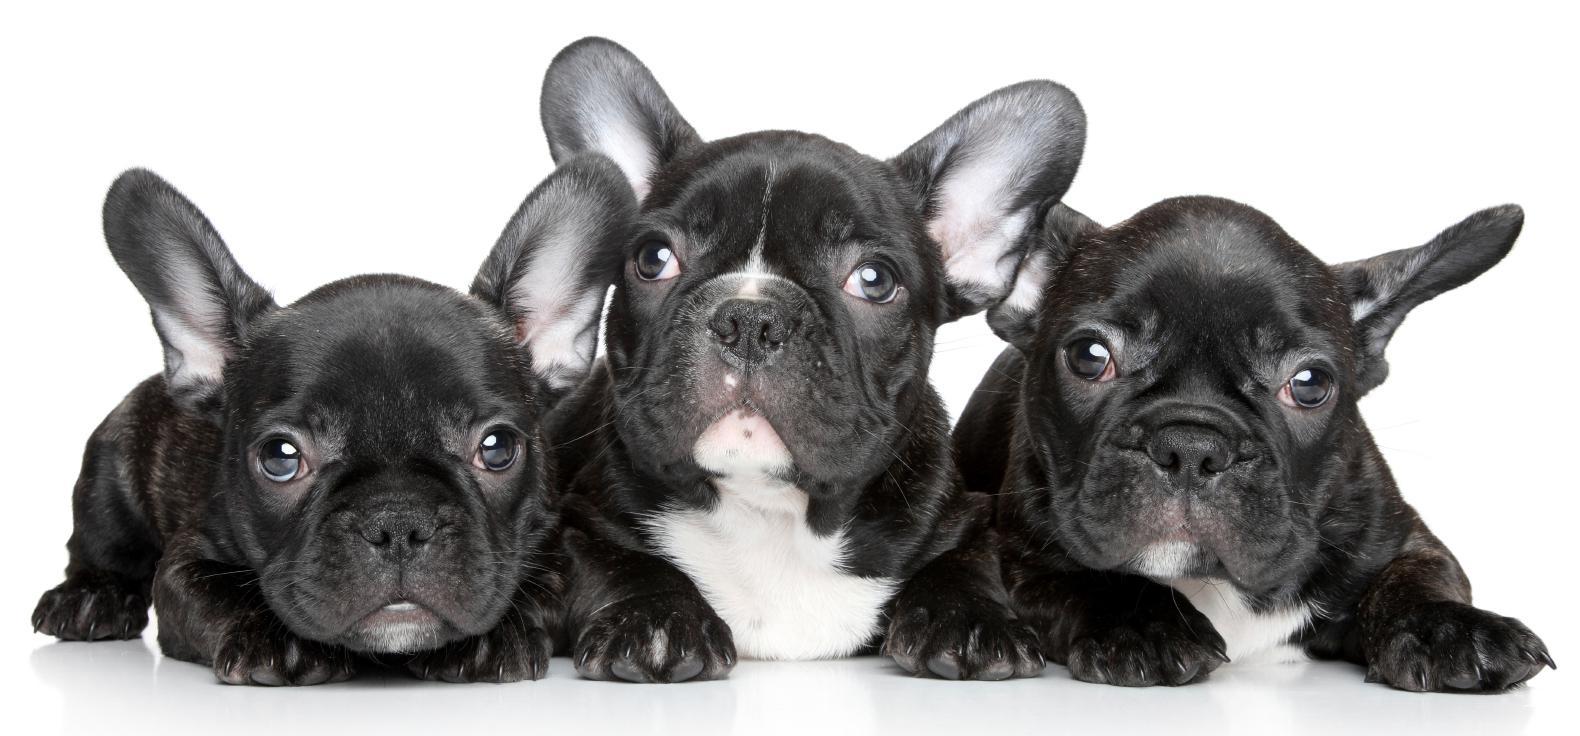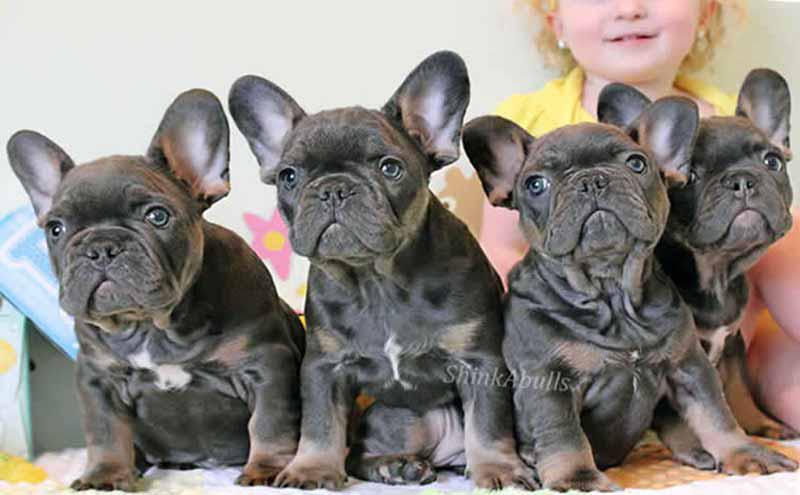The first image is the image on the left, the second image is the image on the right. Considering the images on both sides, is "There are seven dogs." valid? Answer yes or no. Yes. 